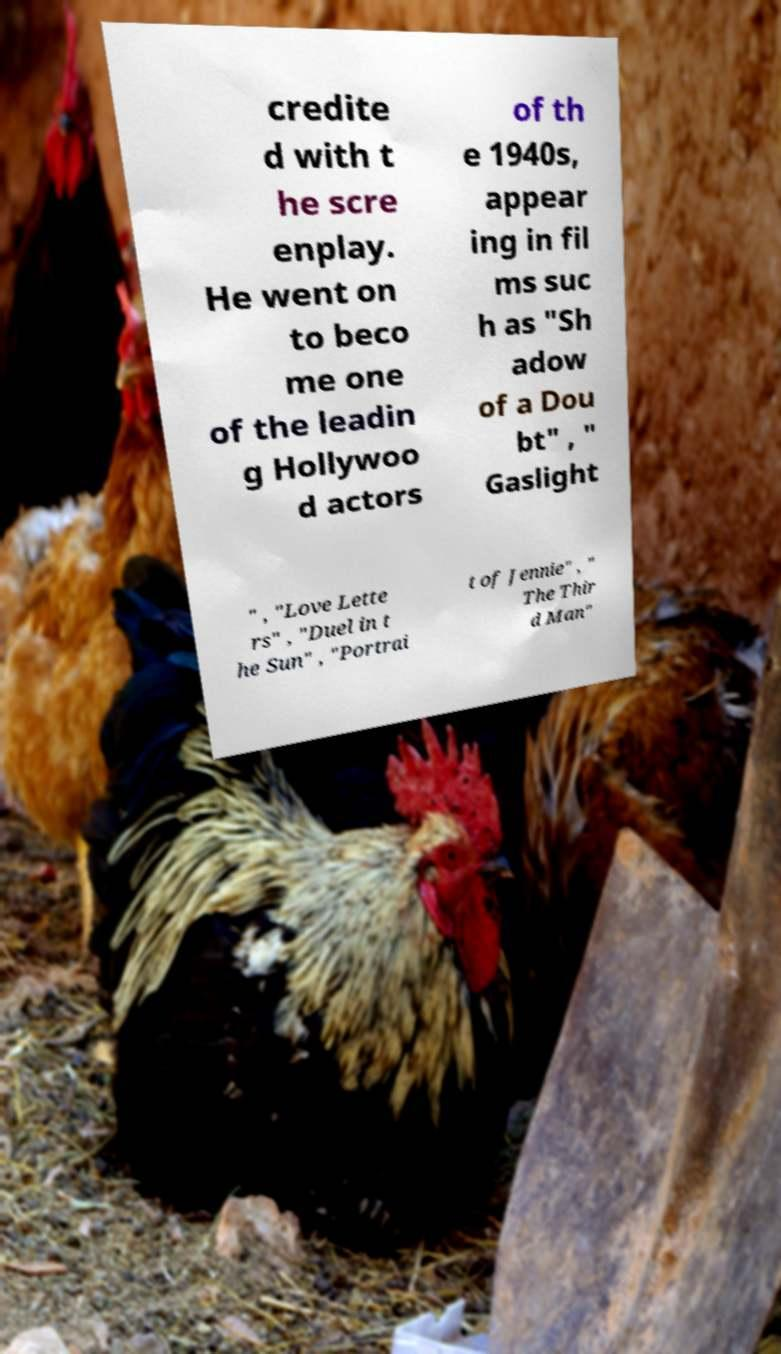Can you read and provide the text displayed in the image?This photo seems to have some interesting text. Can you extract and type it out for me? credite d with t he scre enplay. He went on to beco me one of the leadin g Hollywoo d actors of th e 1940s, appear ing in fil ms suc h as "Sh adow of a Dou bt" , " Gaslight " , "Love Lette rs" , "Duel in t he Sun" , "Portrai t of Jennie" , " The Thir d Man" 